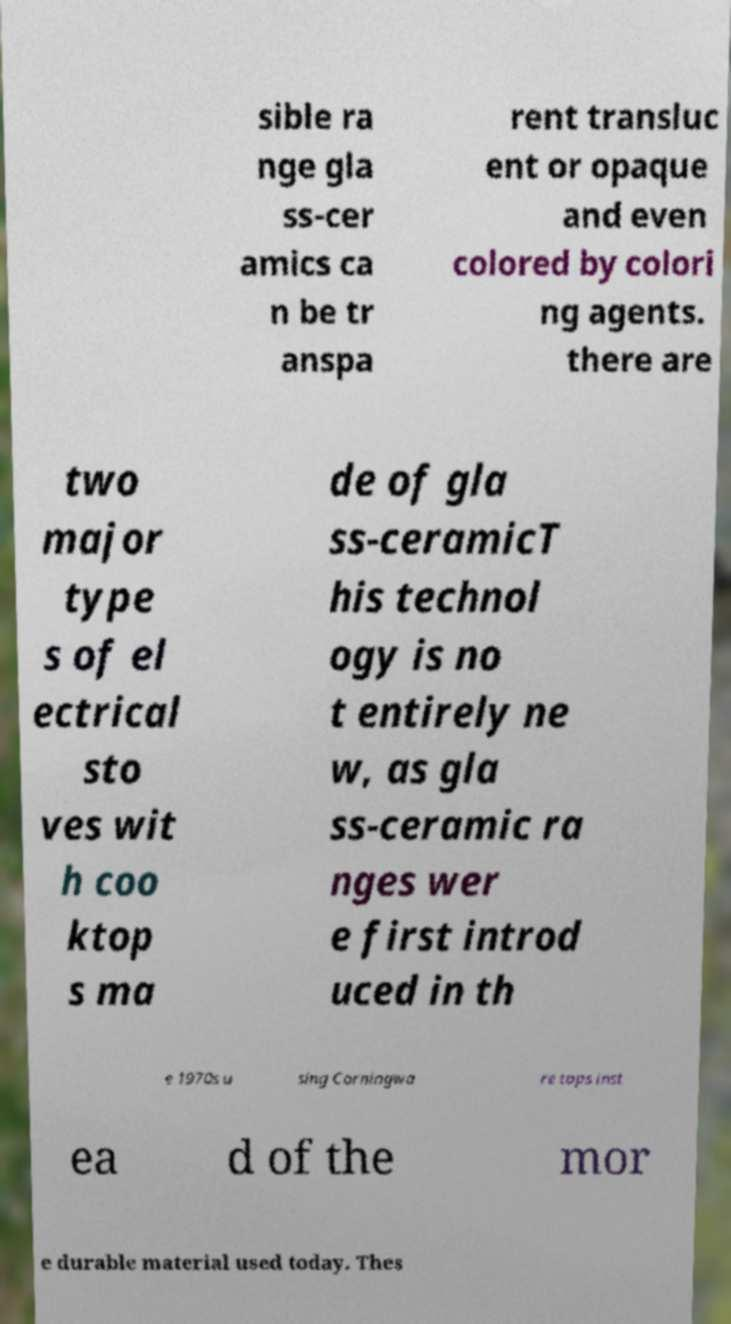Please identify and transcribe the text found in this image. sible ra nge gla ss-cer amics ca n be tr anspa rent transluc ent or opaque and even colored by colori ng agents. there are two major type s of el ectrical sto ves wit h coo ktop s ma de of gla ss-ceramicT his technol ogy is no t entirely ne w, as gla ss-ceramic ra nges wer e first introd uced in th e 1970s u sing Corningwa re tops inst ea d of the mor e durable material used today. Thes 